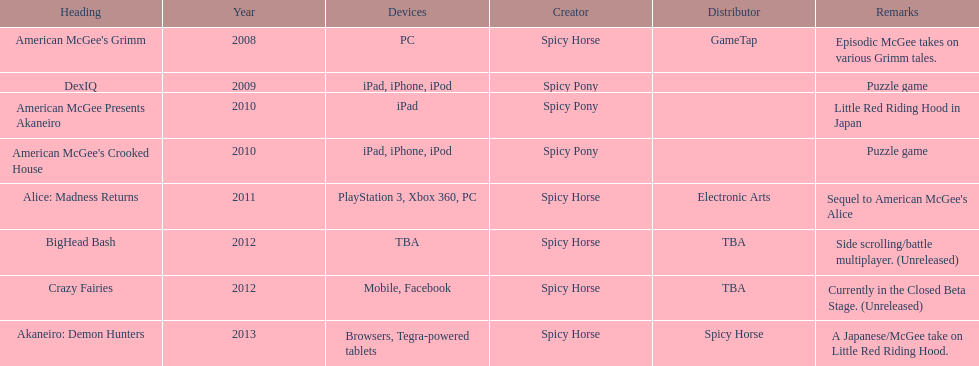What platform was used for the last title on this chart? Browsers, Tegra-powered tablets. 